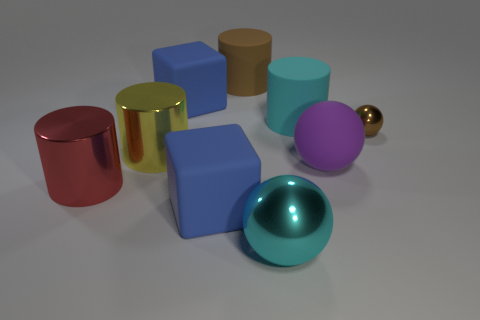Subtract all brown cylinders. How many cylinders are left? 3 Add 1 brown spheres. How many objects exist? 10 Subtract all gray cylinders. Subtract all gray balls. How many cylinders are left? 4 Subtract all cubes. How many objects are left? 7 Subtract all big cubes. Subtract all large red metallic cylinders. How many objects are left? 6 Add 3 brown metallic things. How many brown metallic things are left? 4 Add 1 large cylinders. How many large cylinders exist? 5 Subtract 0 cyan cubes. How many objects are left? 9 